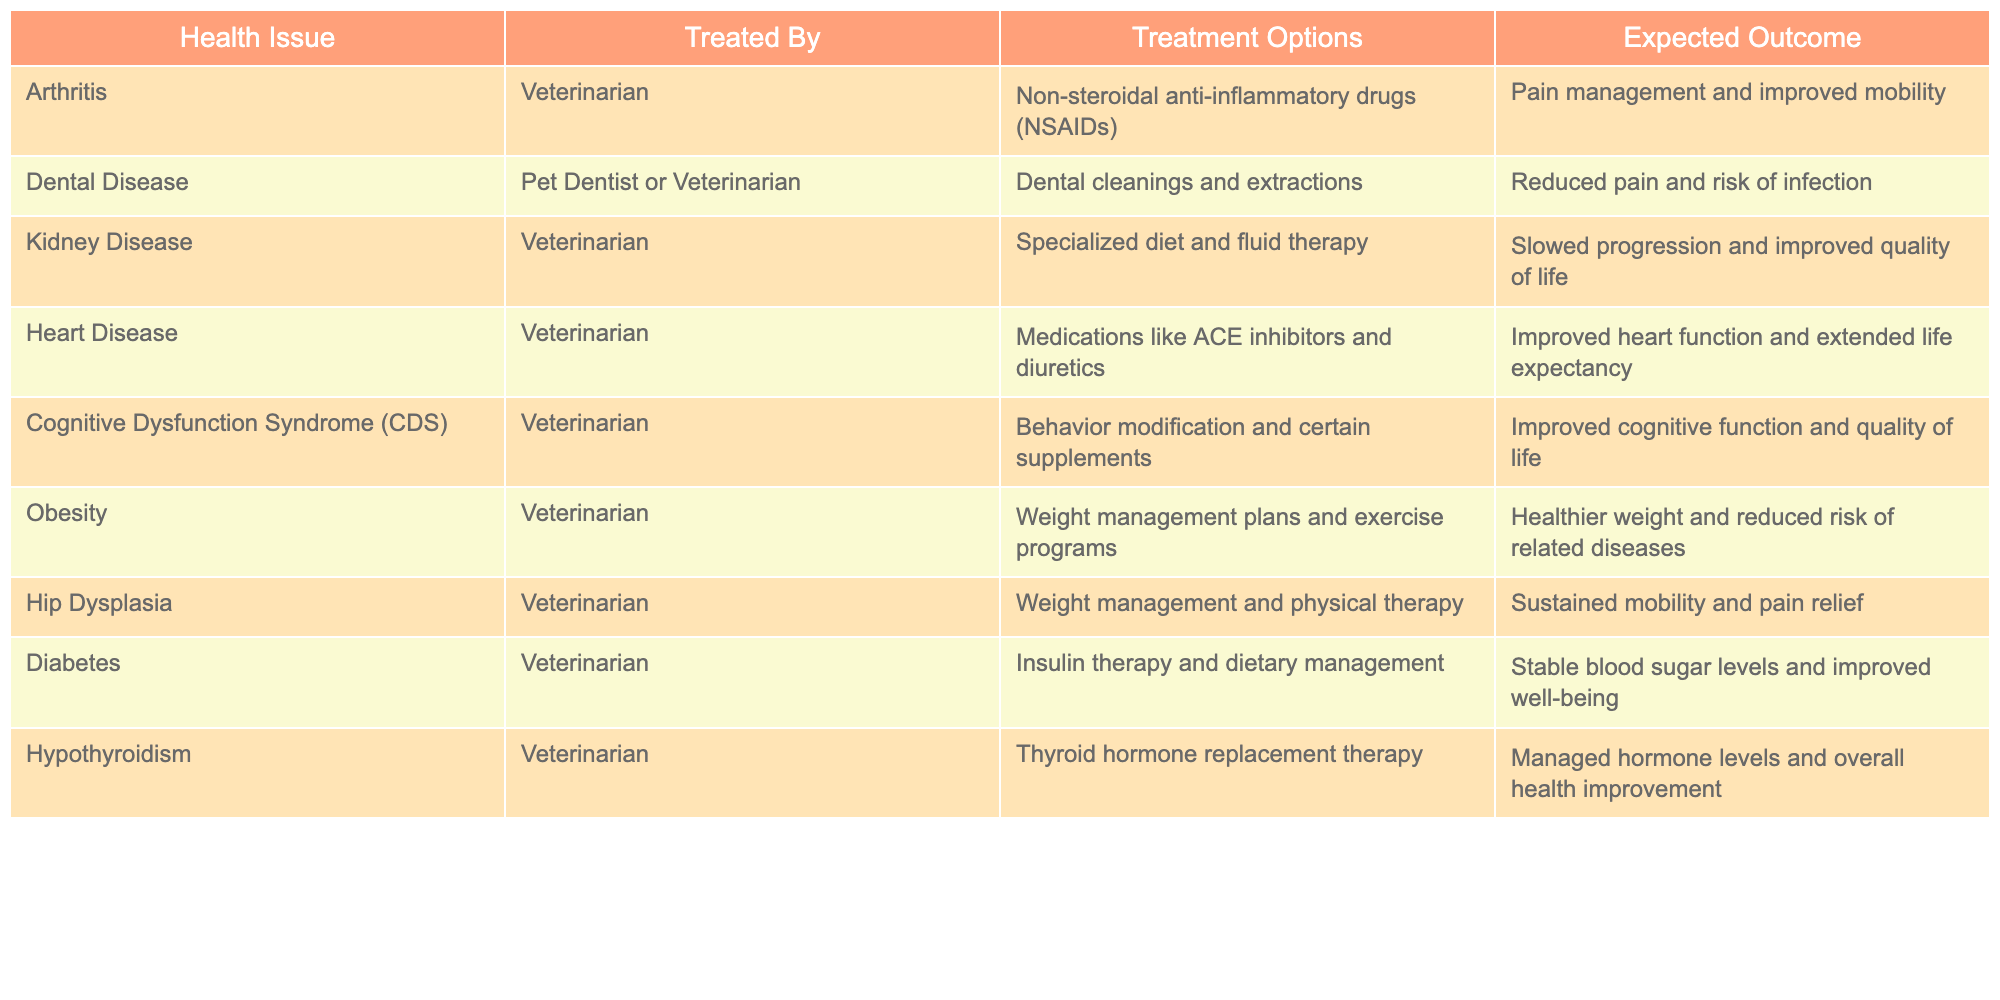What is the expected outcome of treating kidney disease in pets? The table indicates that the treatment for kidney disease involves a specialized diet and fluid therapy, with the expected outcome being slowed progression and improved quality of life.
Answer: Slowed progression and improved quality of life Which health issue requires the treatment of insulin therapy? According to the table, diabetes is the health issue that requires insulin therapy along with dietary management.
Answer: Diabetes What treatment options are available for arthritis? The table lists non-steroidal anti-inflammatory drugs (NSAIDs) as the treatment option for arthritis, aimed at pain management and improved mobility.
Answer: Non-steroidal anti-inflammatory drugs (NSAIDs) Is heart disease treated with exercise programs? The table does not list exercise programs as part of the treatment options for heart disease; instead, it mentions medications like ACE inhibitors and diuretics.
Answer: No Which health issue has treatments that improve cognitive function? The table shows that Cognitive Dysfunction Syndrome (CDS) has treatments focusing on behavior modification and certain supplements, contributing to improved cognitive function and quality of life.
Answer: Cognitive Dysfunction Syndrome (CDS) Which health issue has the longest expected outcome stated in the table? Heart disease treatment includes improved heart function and extended life expectancy, which references a longer timeframe compared to other outcomes listed.
Answer: Heart disease What are the common treatments for obesity in pets? Weight management plans and exercise programs are specified in the table as the common treatments for obesity in pets, promoting a healthier weight and reduced risk of related diseases.
Answer: Weight management plans and exercise programs If a pet has hip dysplasia, what is the primary focus of the treatment? The treatment for hip dysplasia mentioned in the table emphasizes weight management and physical therapy, aiming at sustained mobility and pain relief.
Answer: Weight management and physical therapy Can a pet with hypothyroidism be treated effectively? Yes, the table states that hypothyroidism can be managed with thyroid hormone replacement therapy, leading to managed hormone levels and overall health improvement, indicating its effective treatment.
Answer: Yes How many different health issues are mentioned in the table? By counting the entries in the health issue column of the table, there are a total of 10 different health issues listed.
Answer: 10 